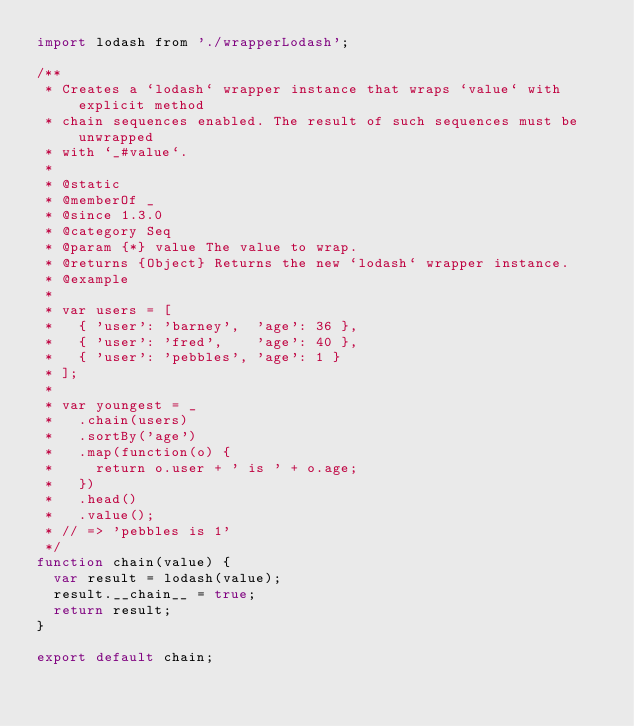<code> <loc_0><loc_0><loc_500><loc_500><_JavaScript_>import lodash from './wrapperLodash';

/**
 * Creates a `lodash` wrapper instance that wraps `value` with explicit method
 * chain sequences enabled. The result of such sequences must be unwrapped
 * with `_#value`.
 *
 * @static
 * @memberOf _
 * @since 1.3.0
 * @category Seq
 * @param {*} value The value to wrap.
 * @returns {Object} Returns the new `lodash` wrapper instance.
 * @example
 *
 * var users = [
 *   { 'user': 'barney',  'age': 36 },
 *   { 'user': 'fred',    'age': 40 },
 *   { 'user': 'pebbles', 'age': 1 }
 * ];
 *
 * var youngest = _
 *   .chain(users)
 *   .sortBy('age')
 *   .map(function(o) {
 *     return o.user + ' is ' + o.age;
 *   })
 *   .head()
 *   .value();
 * // => 'pebbles is 1'
 */
function chain(value) {
  var result = lodash(value);
  result.__chain__ = true;
  return result;
}

export default chain;
</code> 